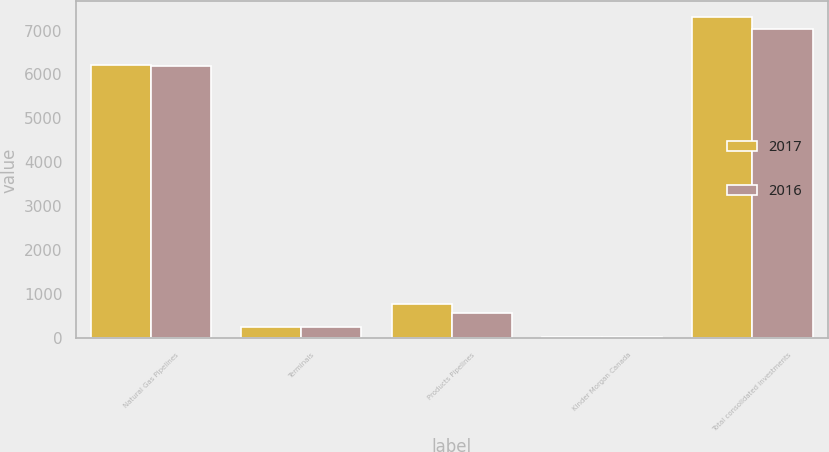Convert chart. <chart><loc_0><loc_0><loc_500><loc_500><stacked_bar_chart><ecel><fcel>Natural Gas Pipelines<fcel>Terminals<fcel>Products Pipelines<fcel>Kinder Morgan Canada<fcel>Total consolidated investments<nl><fcel>2017<fcel>6218<fcel>263<fcel>777<fcel>34<fcel>7298<nl><fcel>2016<fcel>6185<fcel>252<fcel>566<fcel>20<fcel>7027<nl></chart> 